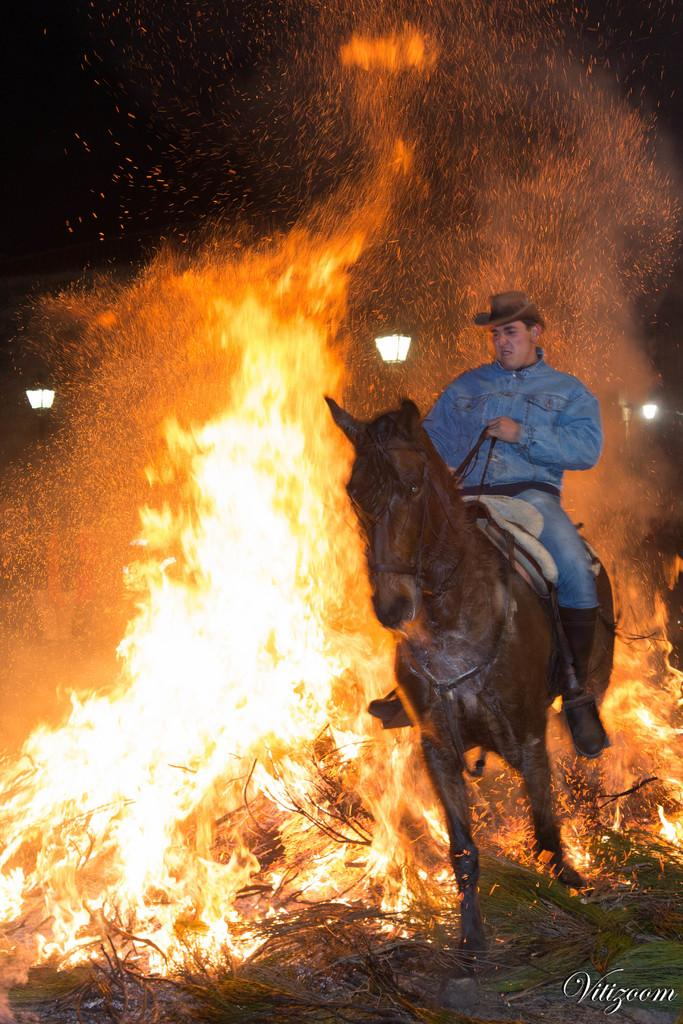Where was the picture taken? The picture was clicked outside. What is the person on the right side of the image doing? The person is riding a horse. What can be seen in the background of the image? There is fire visible in the background. What is present in the bottom right corner of the image? There is text in the bottom right corner of the image. How much glue is required to fix the broken quarter in the image? There is no quarter or glue present in the image, so it is not possible to determine how much glue would be required. 